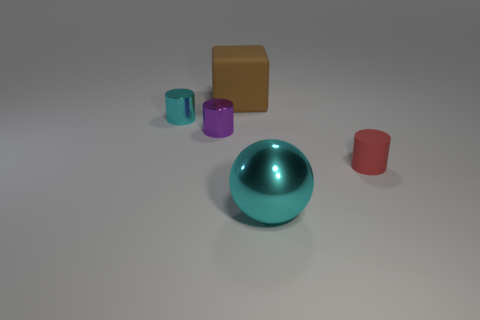Add 1 tiny rubber objects. How many objects exist? 6 Subtract all cylinders. How many objects are left? 2 Add 4 brown matte things. How many brown matte things exist? 5 Subtract 1 red cylinders. How many objects are left? 4 Subtract all cyan metal cylinders. Subtract all purple metal things. How many objects are left? 3 Add 3 brown objects. How many brown objects are left? 4 